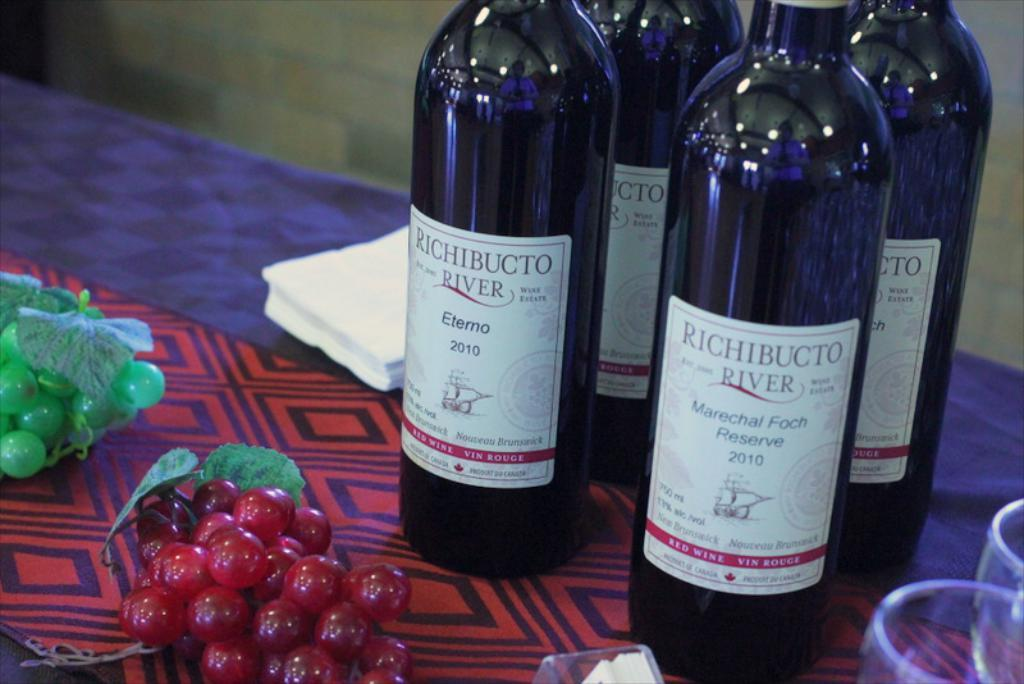Provide a one-sentence caption for the provided image. The four bottles of Richibucto River were on top of the table. 